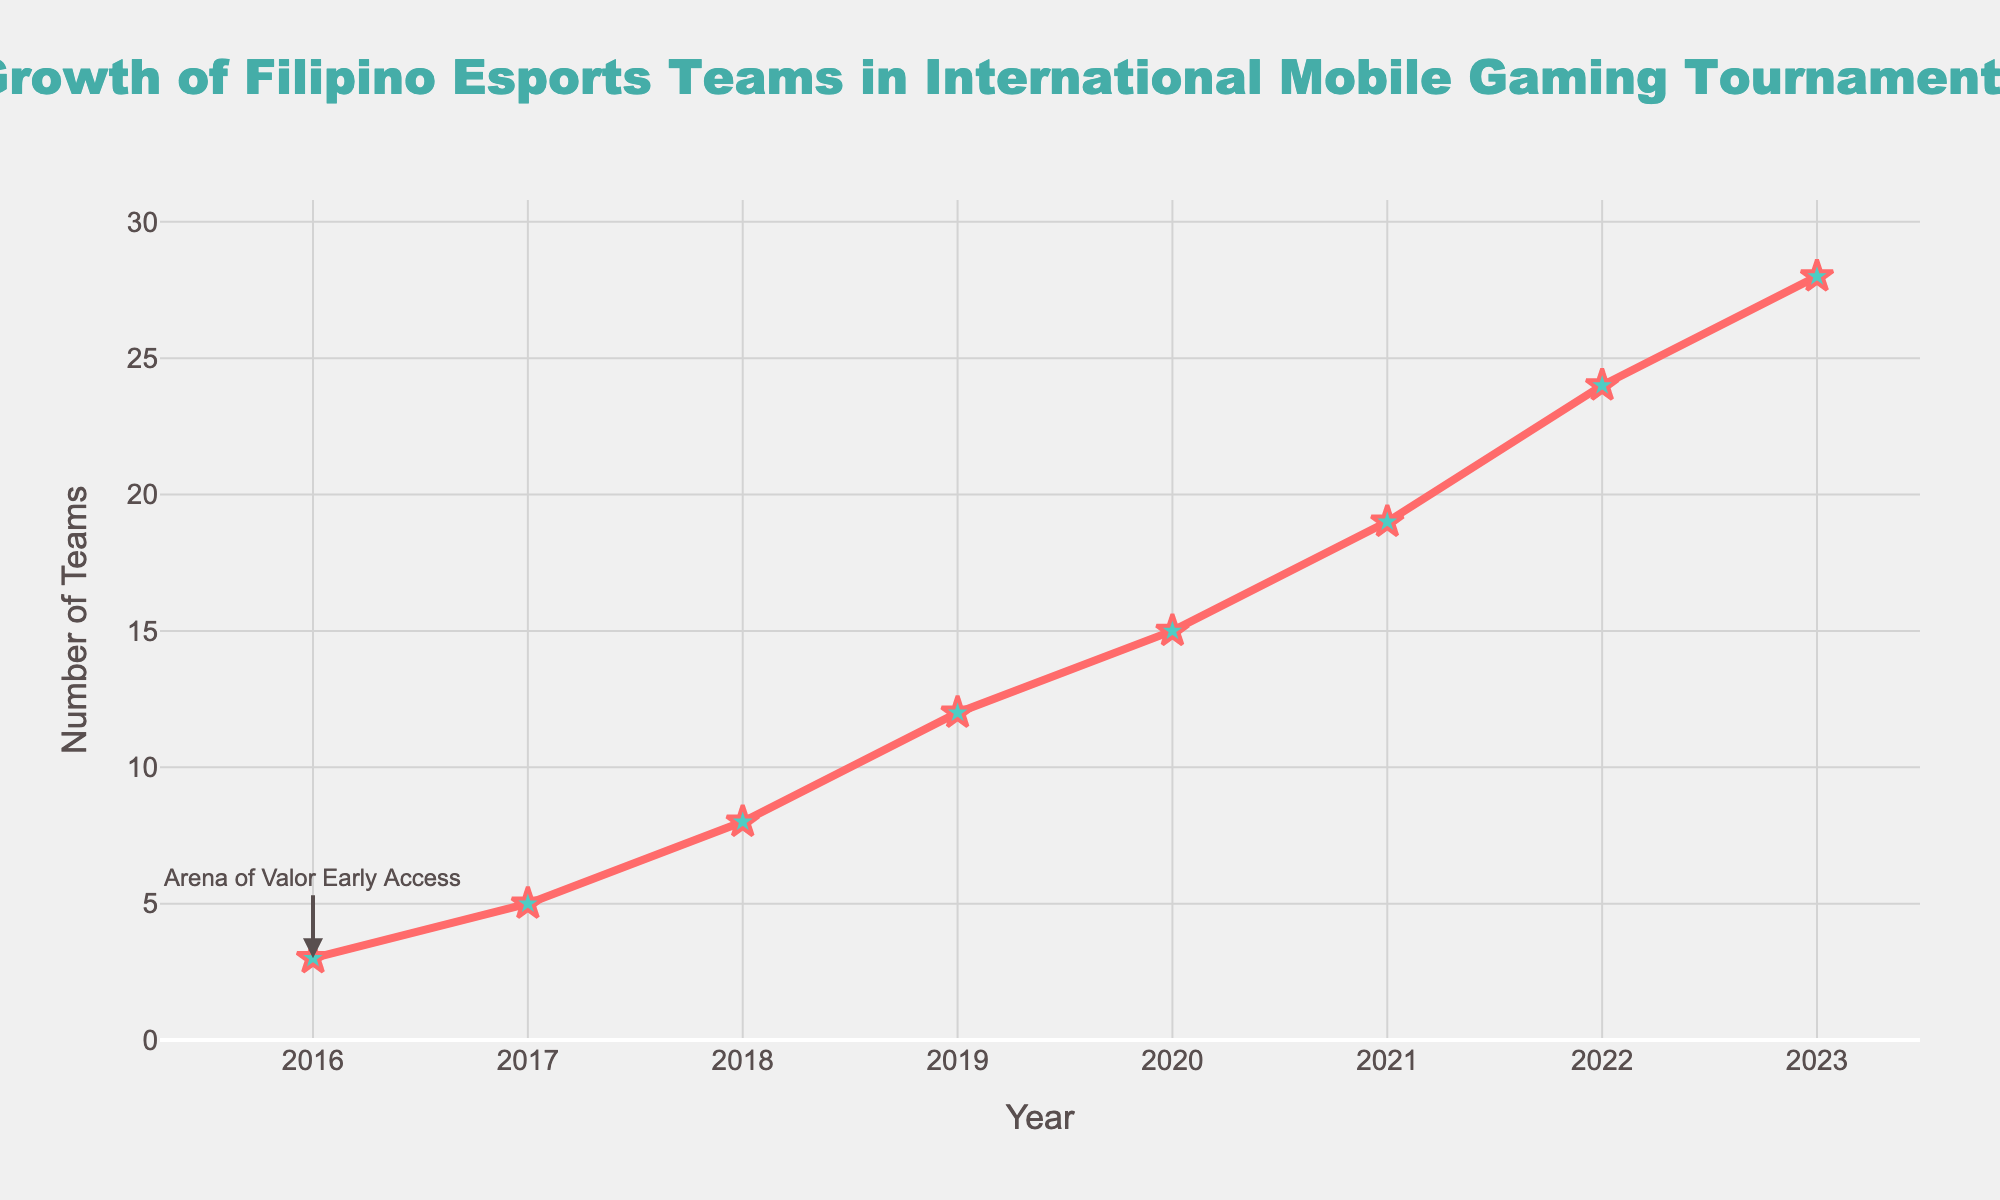What's the number of Filipino esports teams in 2016 and 2018? To answer this, locate the values corresponding to the years 2016 and 2018. In 2016, the value is 3 teams. In 2018, the value is 8 teams.
Answer: 3 teams in 2016, 8 teams in 2018 What's the difference in the number of teams between 2022 and 2017? Locate the values for 2022 and 2017 in the figure. In 2022, there are 24 teams. In 2017, there are 5 teams. Subtract 5 from 24 to find the difference: 24 - 5 = 19.
Answer: 19 teams What is the average number of teams from 2016 to 2018? Find the values for the years 2016, 2017, and 2018: 3, 5, and 8. Calculate the average by summing these values and dividing by 3: (3 + 5 + 8) / 3 = 16 / 3 ≈ 5.33.
Answer: 5.33 Between which years did the number of teams grow the most? Observe the differences between consecutive years. The increase from 2018 to 2019 is (12 - 8 = 4), from 2019 to 2020 is (15 - 12 = 3),  from 2020 to 2021 is (19 - 15 = 4), and from 2021 to 2022 is (24 - 19 = 5). The largest increase is 5, between 2021 and 2022.
Answer: Between 2021 and 2022 What color represents the line of the number of Filipino esports teams on the graph? Look at the visual attributes of the line representing the data. It is depicted in red.
Answer: Red 